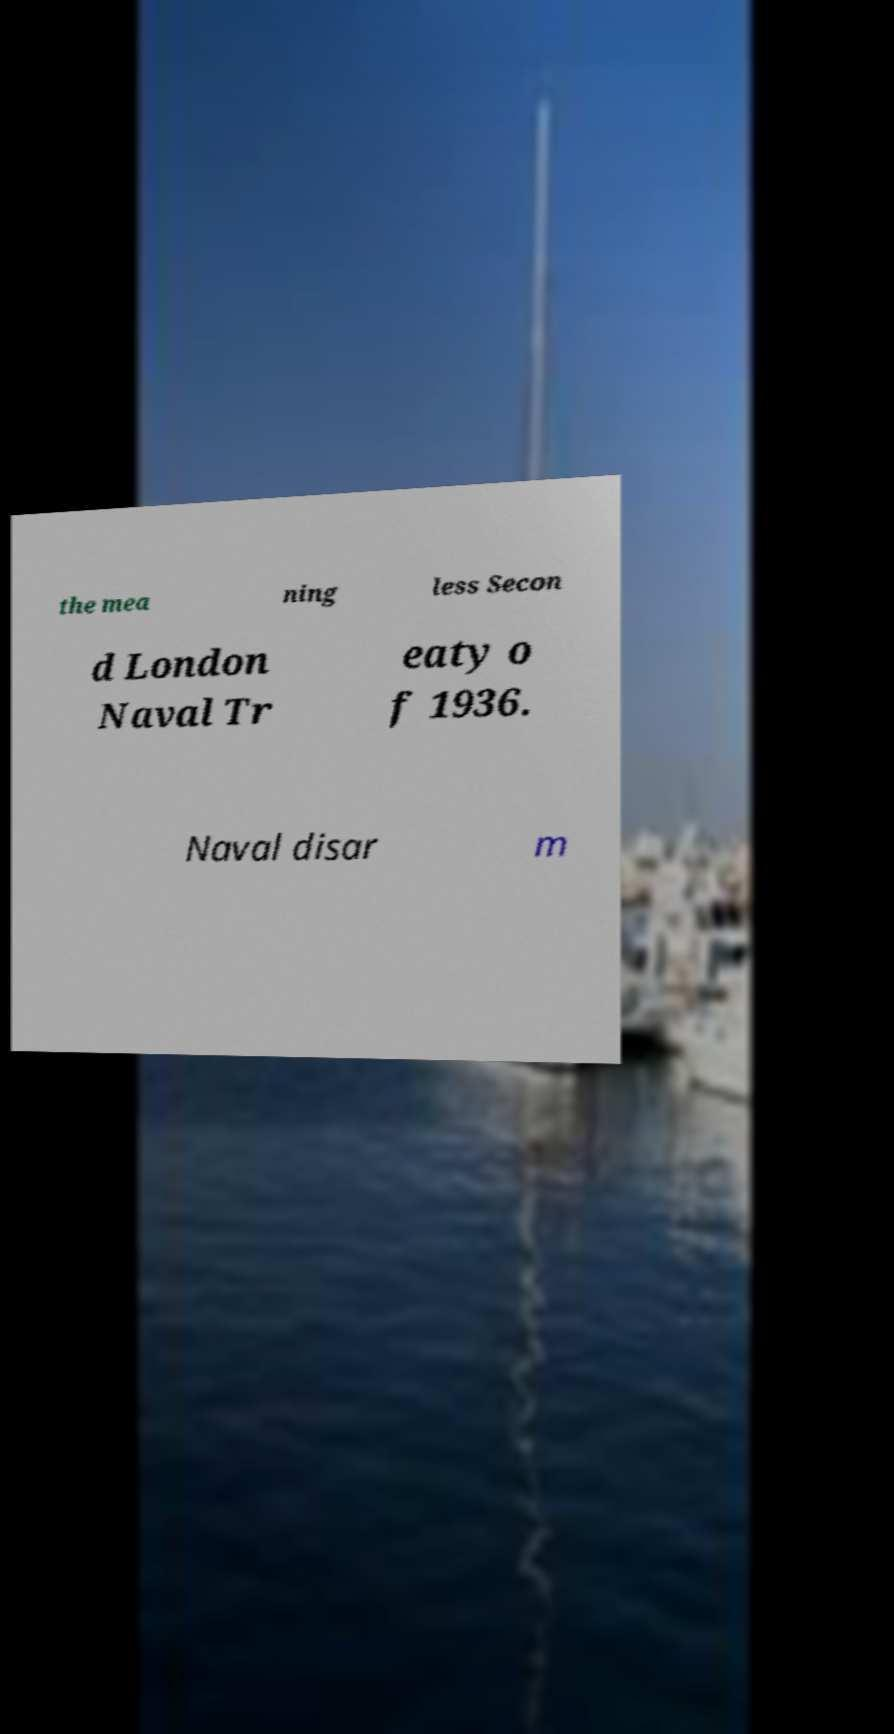There's text embedded in this image that I need extracted. Can you transcribe it verbatim? the mea ning less Secon d London Naval Tr eaty o f 1936. Naval disar m 